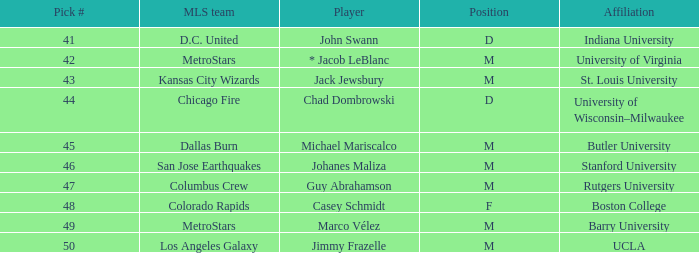In the mls, which team holds the selection number 41? D.C. United. 